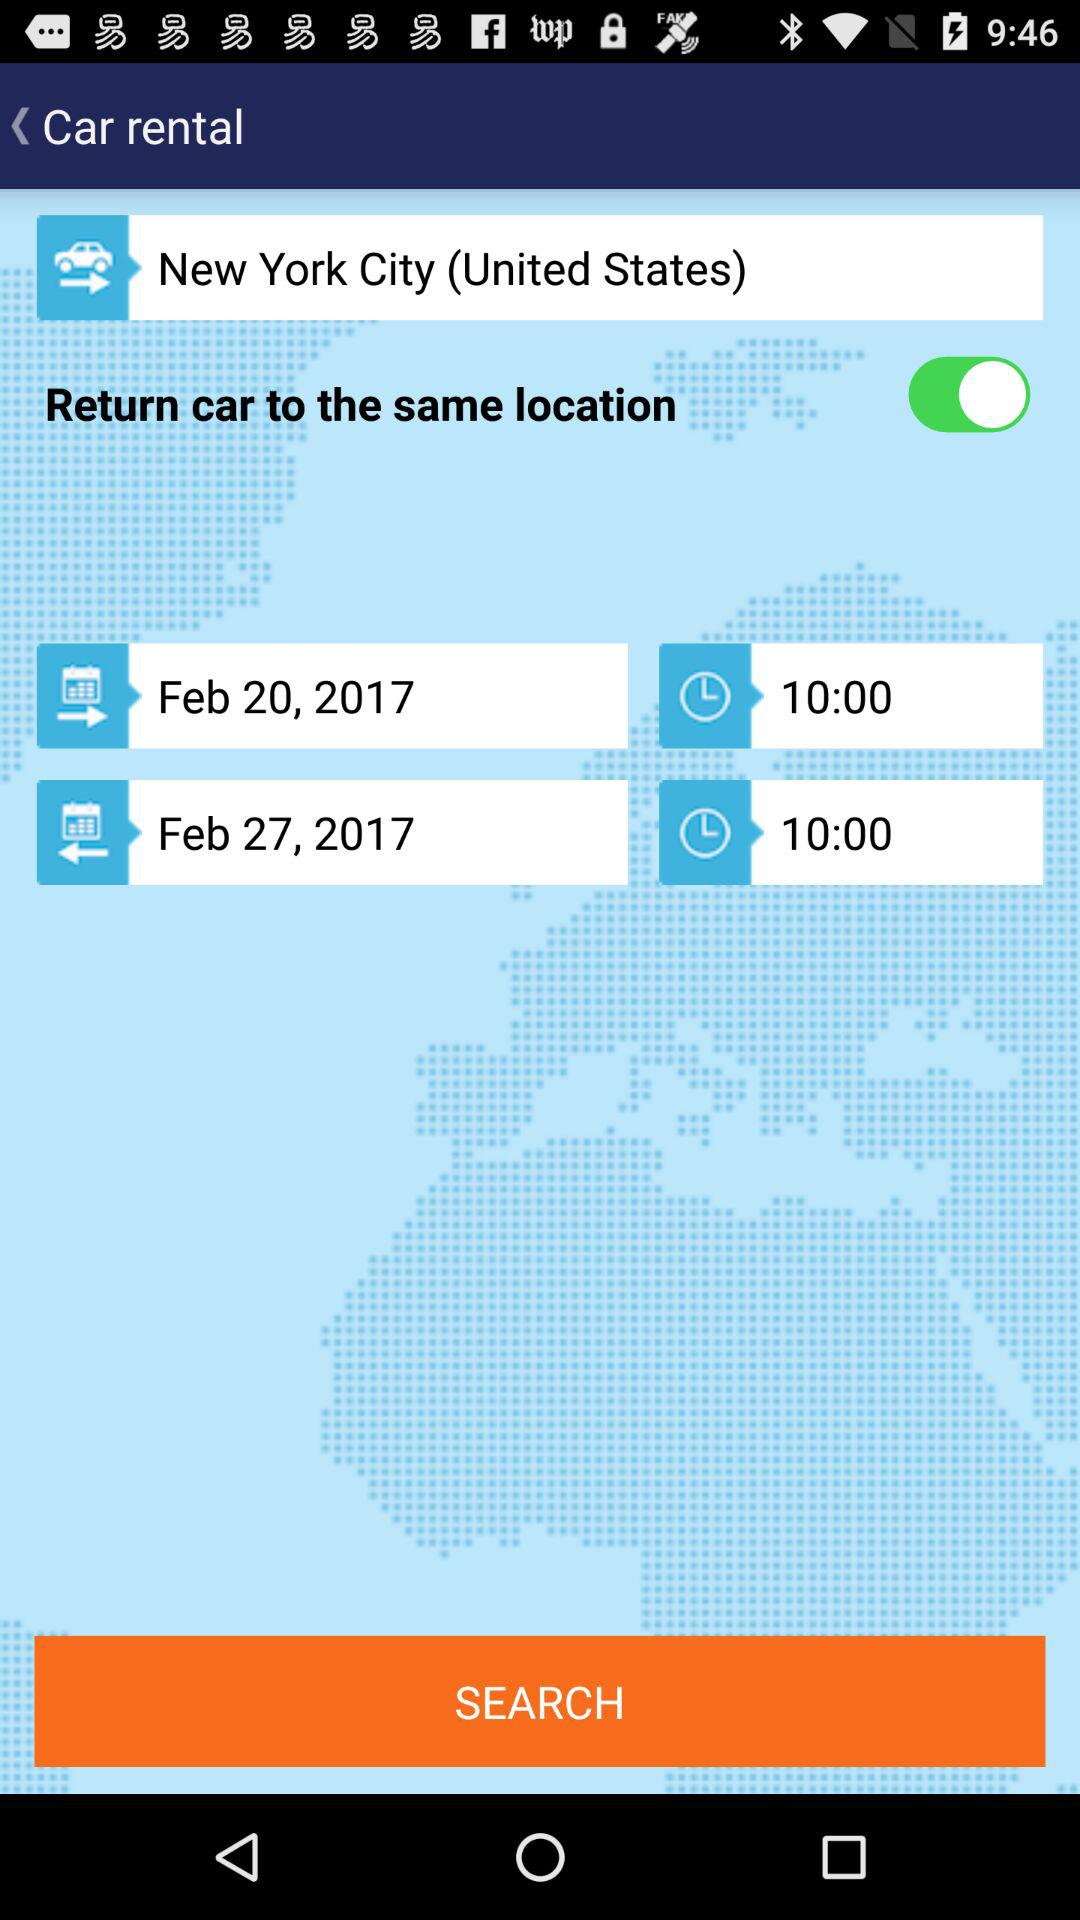What is the departure time? The departure time is 10:00. 